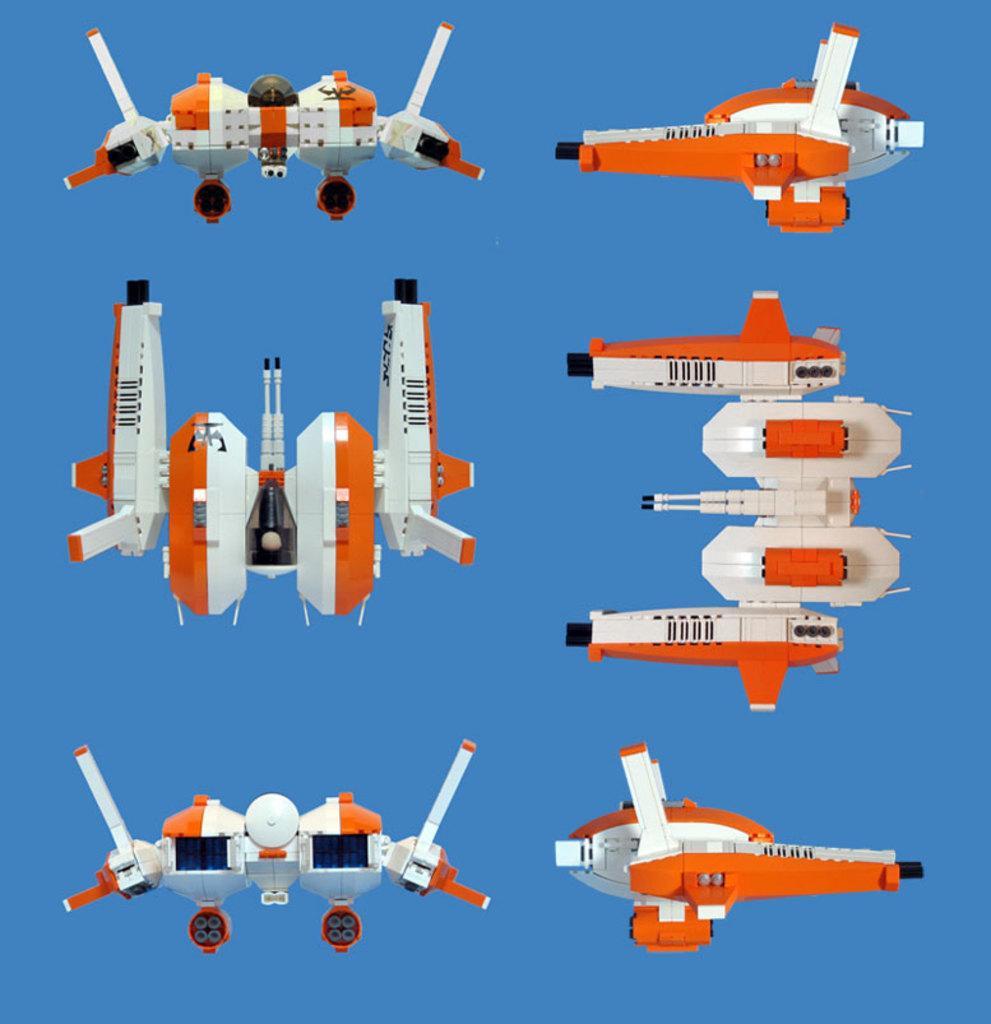Could you give a brief overview of what you see in this image? In this image there are gadgets, in the background it is in blue color. 